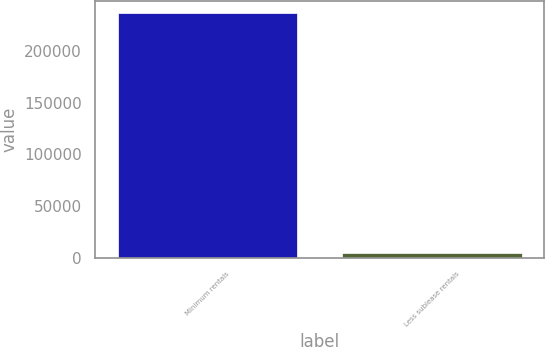Convert chart. <chart><loc_0><loc_0><loc_500><loc_500><bar_chart><fcel>Minimum rentals<fcel>Less sublease rentals<nl><fcel>236965<fcel>4673<nl></chart> 